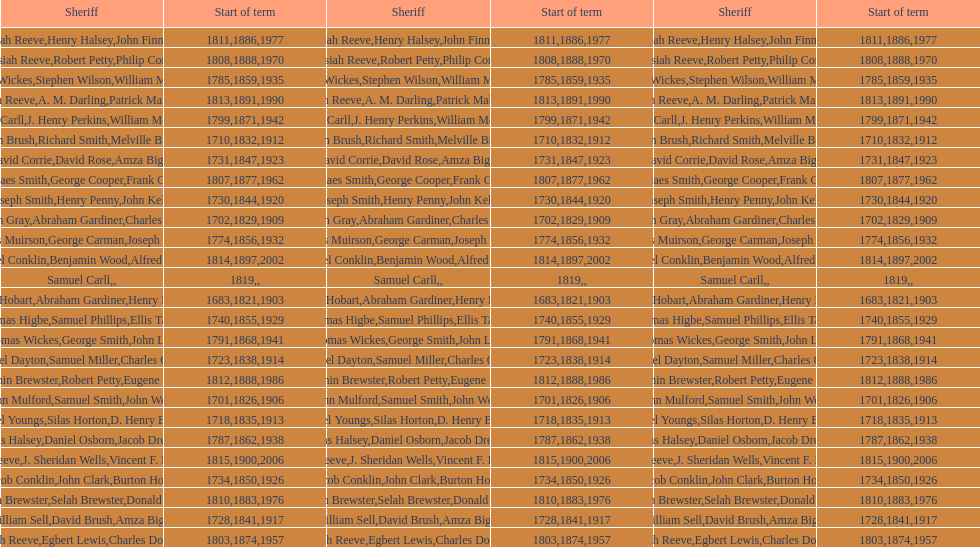What is the count of sheriffs with the surname smith? 5. 